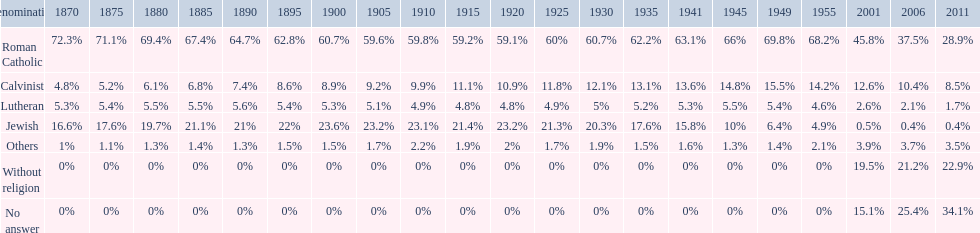In which year was the percentage of those without religion at least 20%? 2011. 